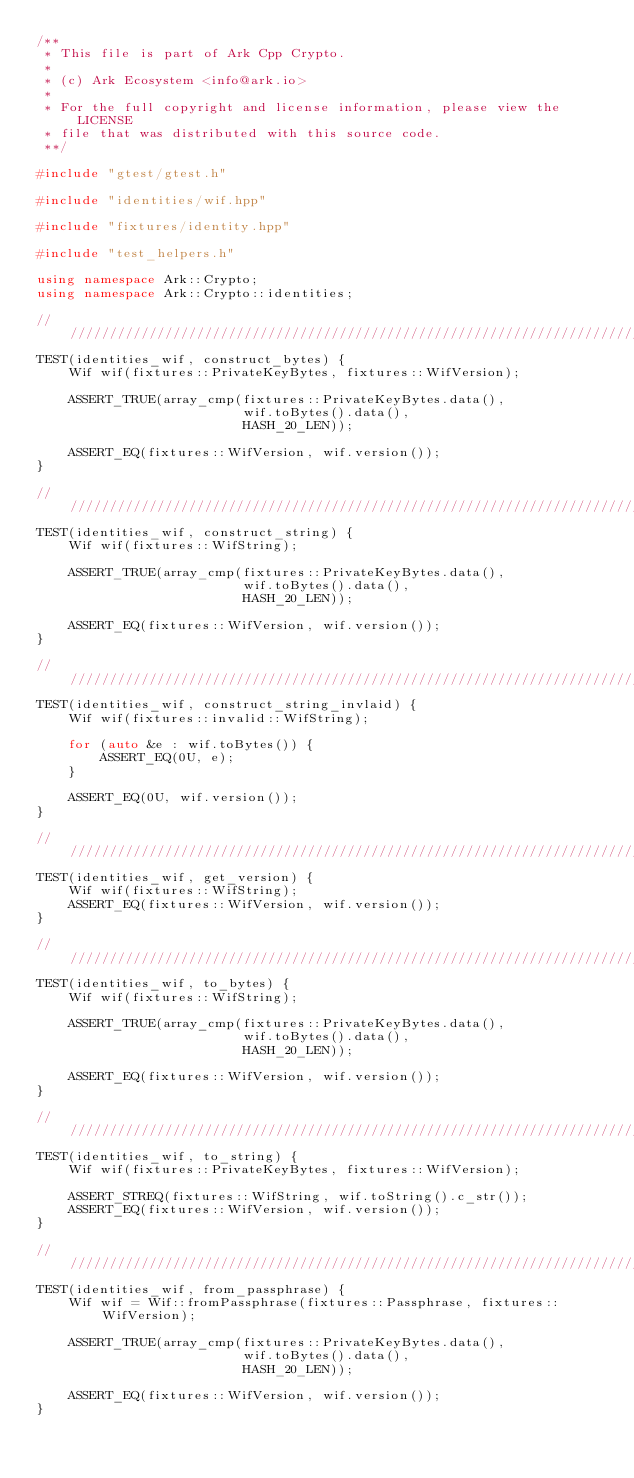Convert code to text. <code><loc_0><loc_0><loc_500><loc_500><_C++_>/**
 * This file is part of Ark Cpp Crypto.
 *
 * (c) Ark Ecosystem <info@ark.io>
 *
 * For the full copyright and license information, please view the LICENSE
 * file that was distributed with this source code.
 **/

#include "gtest/gtest.h"

#include "identities/wif.hpp"

#include "fixtures/identity.hpp"

#include "test_helpers.h"

using namespace Ark::Crypto;
using namespace Ark::Crypto::identities;

////////////////////////////////////////////////////////////////////////////////
TEST(identities_wif, construct_bytes) {
    Wif wif(fixtures::PrivateKeyBytes, fixtures::WifVersion);

    ASSERT_TRUE(array_cmp(fixtures::PrivateKeyBytes.data(),
                          wif.toBytes().data(),
                          HASH_20_LEN));

    ASSERT_EQ(fixtures::WifVersion, wif.version());
}

////////////////////////////////////////////////////////////////////////////////
TEST(identities_wif, construct_string) {
    Wif wif(fixtures::WifString);

    ASSERT_TRUE(array_cmp(fixtures::PrivateKeyBytes.data(),
                          wif.toBytes().data(),
                          HASH_20_LEN));

    ASSERT_EQ(fixtures::WifVersion, wif.version());
}

////////////////////////////////////////////////////////////////////////////////
TEST(identities_wif, construct_string_invlaid) {
    Wif wif(fixtures::invalid::WifString);

    for (auto &e : wif.toBytes()) {
        ASSERT_EQ(0U, e);
    }

    ASSERT_EQ(0U, wif.version());
}

////////////////////////////////////////////////////////////////////////////////
TEST(identities_wif, get_version) {
    Wif wif(fixtures::WifString);
    ASSERT_EQ(fixtures::WifVersion, wif.version());
}

////////////////////////////////////////////////////////////////////////////////
TEST(identities_wif, to_bytes) {
    Wif wif(fixtures::WifString);

    ASSERT_TRUE(array_cmp(fixtures::PrivateKeyBytes.data(),
                          wif.toBytes().data(),
                          HASH_20_LEN));

    ASSERT_EQ(fixtures::WifVersion, wif.version());
}

////////////////////////////////////////////////////////////////////////////////
TEST(identities_wif, to_string) {
    Wif wif(fixtures::PrivateKeyBytes, fixtures::WifVersion);

    ASSERT_STREQ(fixtures::WifString, wif.toString().c_str());
    ASSERT_EQ(fixtures::WifVersion, wif.version());
}

////////////////////////////////////////////////////////////////////////////////
TEST(identities_wif, from_passphrase) {
    Wif wif = Wif::fromPassphrase(fixtures::Passphrase, fixtures::WifVersion);

    ASSERT_TRUE(array_cmp(fixtures::PrivateKeyBytes.data(),
                          wif.toBytes().data(),
                          HASH_20_LEN));

    ASSERT_EQ(fixtures::WifVersion, wif.version());
}
</code> 